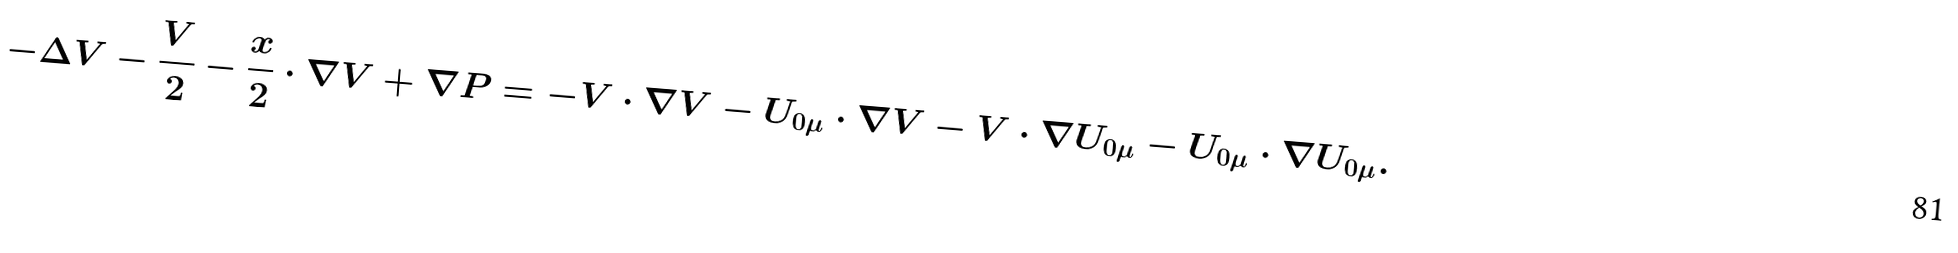Convert formula to latex. <formula><loc_0><loc_0><loc_500><loc_500>- \Delta V - \frac { V } { 2 } - \frac { x } { 2 } \cdot \nabla V + \nabla P = - V \cdot \nabla V - U _ { 0 \mu } \cdot \nabla V - V \cdot \nabla U _ { 0 \mu } - U _ { 0 \mu } \cdot \nabla U _ { 0 \mu } .</formula> 